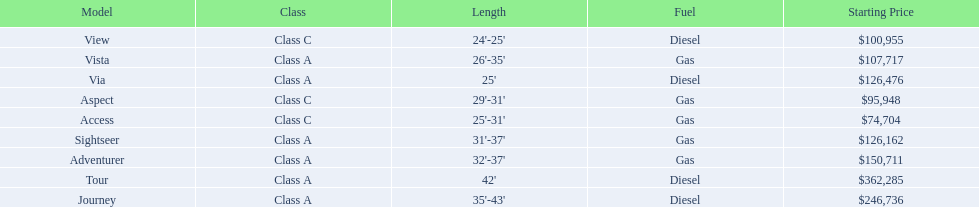How many models are available in lengths longer than 30 feet? 7. 